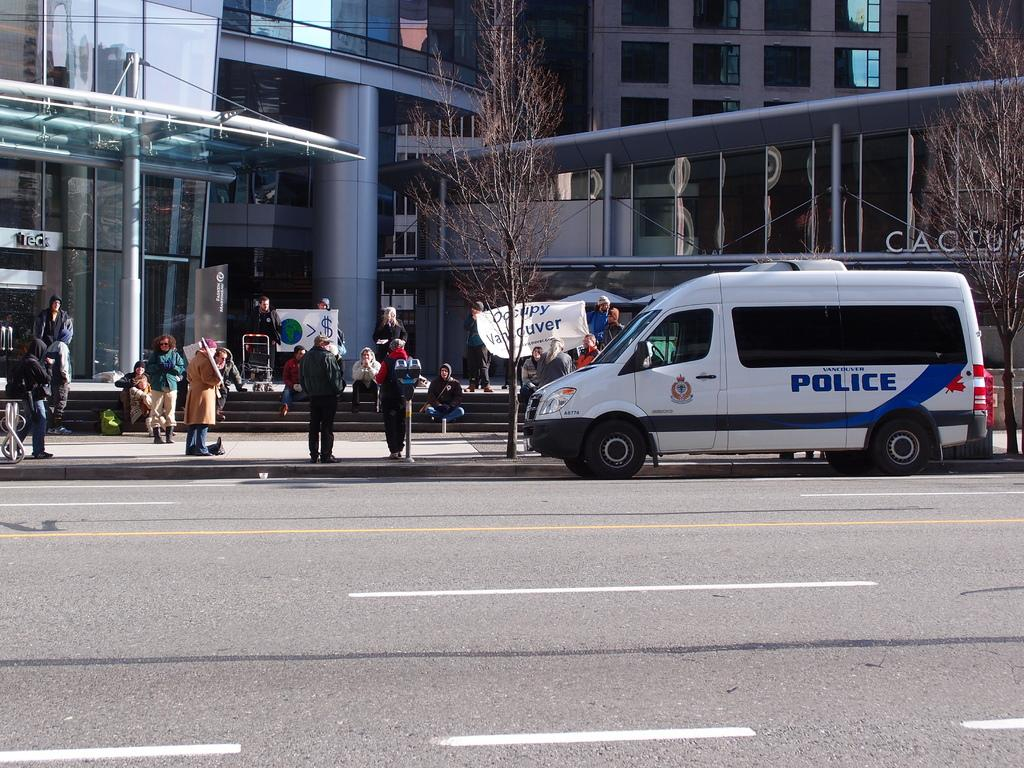<image>
Describe the image concisely. A white police van is parked in front of a group of protesters. 